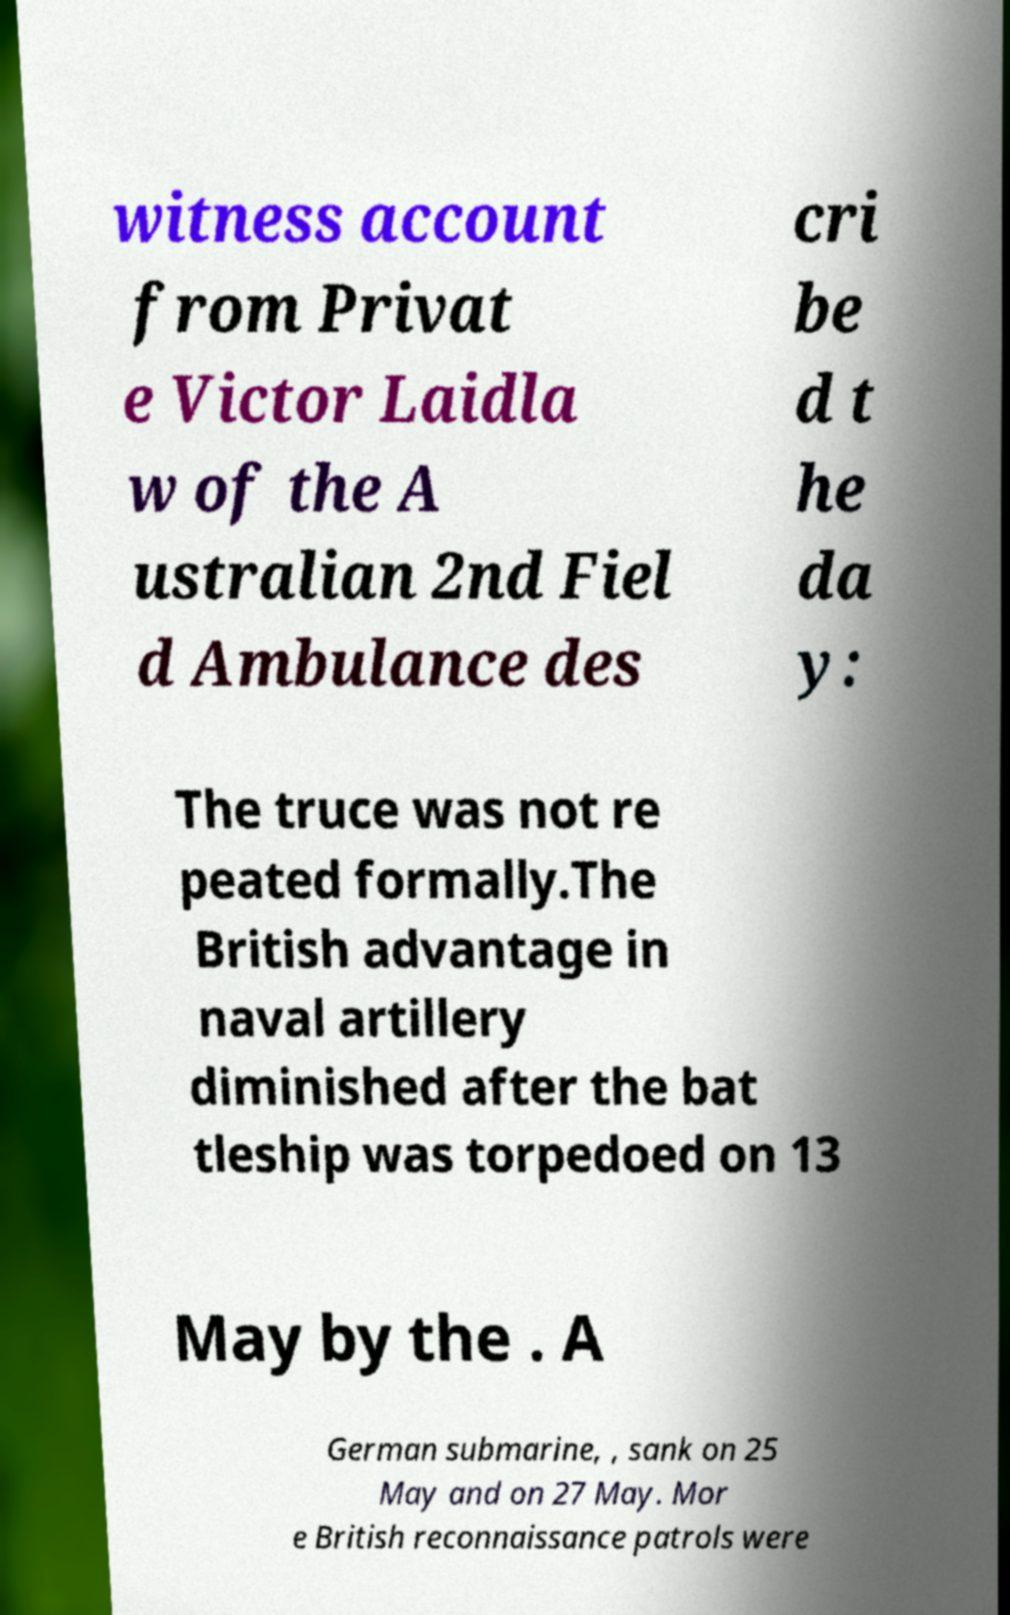Could you assist in decoding the text presented in this image and type it out clearly? witness account from Privat e Victor Laidla w of the A ustralian 2nd Fiel d Ambulance des cri be d t he da y: The truce was not re peated formally.The British advantage in naval artillery diminished after the bat tleship was torpedoed on 13 May by the . A German submarine, , sank on 25 May and on 27 May. Mor e British reconnaissance patrols were 